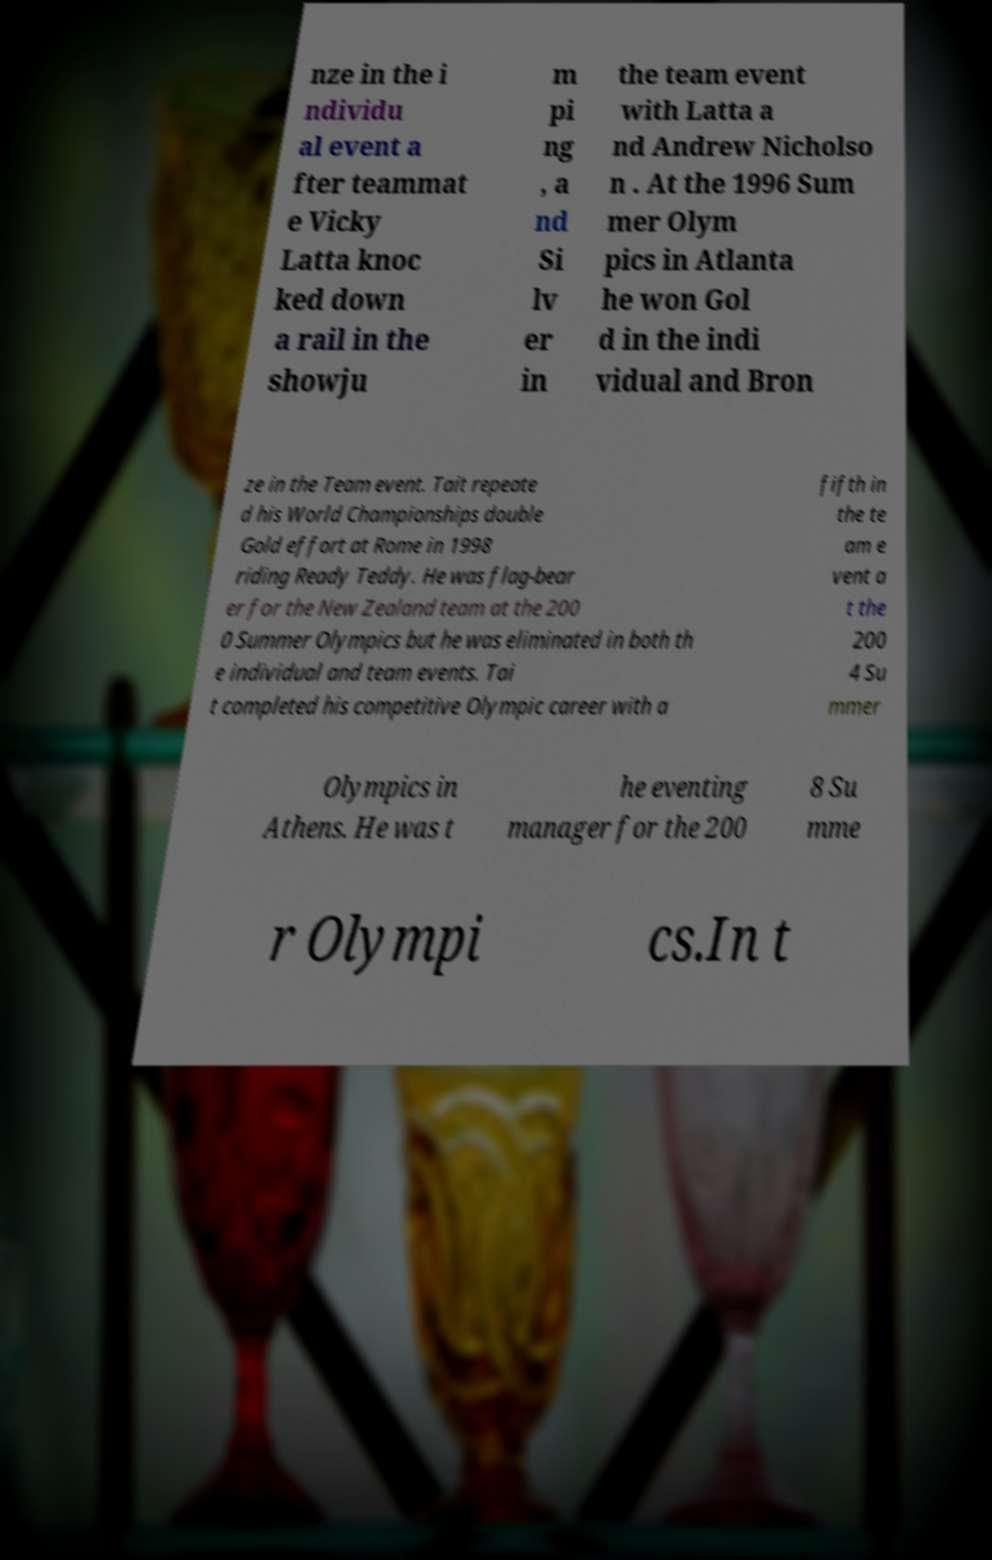What messages or text are displayed in this image? I need them in a readable, typed format. nze in the i ndividu al event a fter teammat e Vicky Latta knoc ked down a rail in the showju m pi ng , a nd Si lv er in the team event with Latta a nd Andrew Nicholso n . At the 1996 Sum mer Olym pics in Atlanta he won Gol d in the indi vidual and Bron ze in the Team event. Tait repeate d his World Championships double Gold effort at Rome in 1998 riding Ready Teddy. He was flag-bear er for the New Zealand team at the 200 0 Summer Olympics but he was eliminated in both th e individual and team events. Tai t completed his competitive Olympic career with a fifth in the te am e vent a t the 200 4 Su mmer Olympics in Athens. He was t he eventing manager for the 200 8 Su mme r Olympi cs.In t 